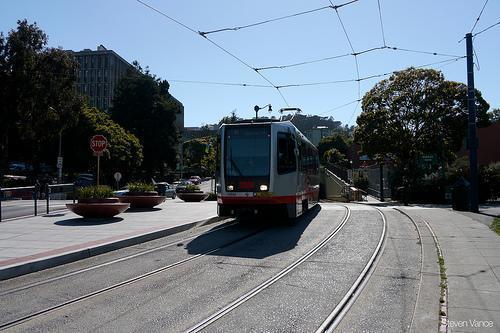How many stop signs are there?
Give a very brief answer. 1. How many people are running front of the train?
Give a very brief answer. 0. 